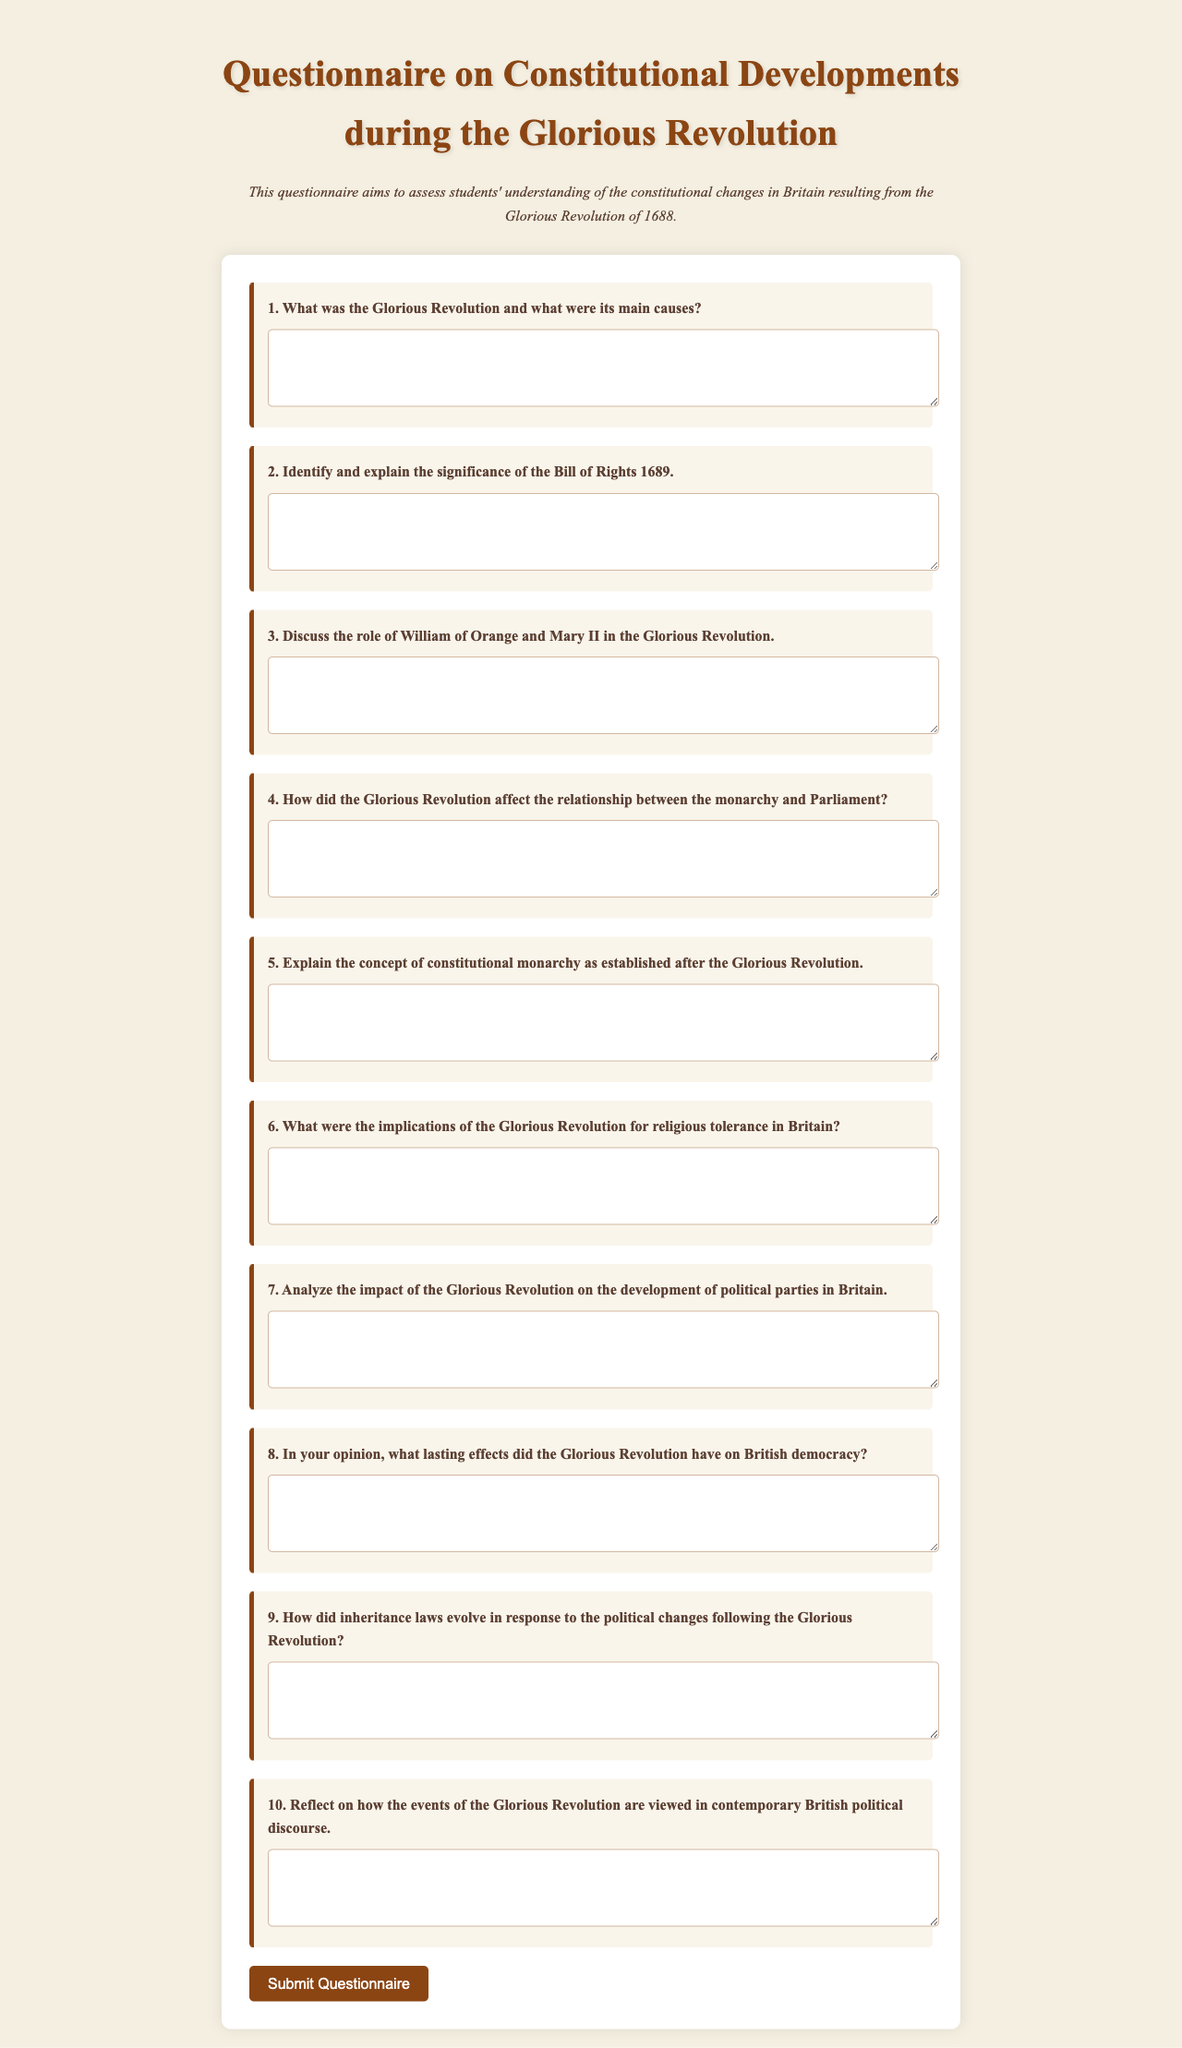What is the title of the document? The title is presented in the header and states the subject of the questionnaire.
Answer: Questionnaire on Constitutional Developments during the Glorious Revolution How many questions are in the form? The form contains a numbered list of questions that can be counted.
Answer: 10 What significant document is specifically mentioned in question 2? Question 2 references a key legal document associated with the Glorious Revolution.
Answer: Bill of Rights 1689 Who are the two primary figures mentioned in question 3? Question 3 asks about the role of specific historical figures during the Glorious Revolution.
Answer: William of Orange and Mary II What concept is explained in question 5? Question 5 focuses on the governmental structure established post-Revolution.
Answer: Constitutional monarchy What change in religious policy is addressed in question 6? Question 6 explores the implications of the Glorious Revolution regarding a social aspect.
Answer: Religious tolerance Which historical event is being assessed in this questionnaire? The event is the focus of the entire document as stated in the introduction.
Answer: Glorious Revolution What is the main focus of question 9? Question 9 links the political changes of the period with a specific legal concern.
Answer: Inheritance laws How does the questionnaire expect respondents to reflect in question 10? Question 10 asks for a personal assessment on a relevant topic in modern context.
Answer: Contemporary British political discourse 